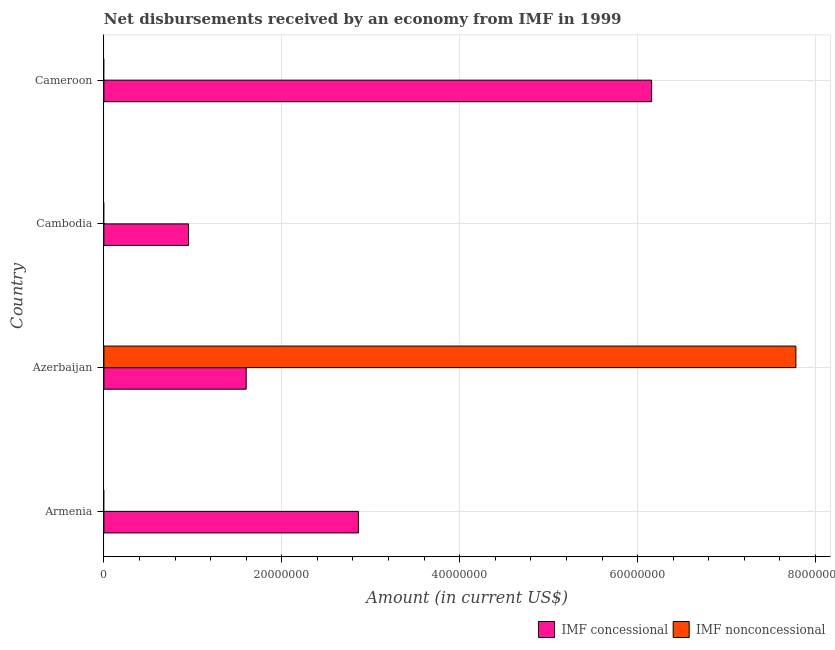Are the number of bars on each tick of the Y-axis equal?
Your answer should be very brief. No. How many bars are there on the 2nd tick from the top?
Give a very brief answer. 1. How many bars are there on the 3rd tick from the bottom?
Keep it short and to the point. 1. What is the label of the 3rd group of bars from the top?
Give a very brief answer. Azerbaijan. In how many cases, is the number of bars for a given country not equal to the number of legend labels?
Provide a succinct answer. 3. What is the net concessional disbursements from imf in Cambodia?
Provide a short and direct response. 9.51e+06. Across all countries, what is the maximum net non concessional disbursements from imf?
Your response must be concise. 7.78e+07. Across all countries, what is the minimum net concessional disbursements from imf?
Keep it short and to the point. 9.51e+06. In which country was the net non concessional disbursements from imf maximum?
Your response must be concise. Azerbaijan. What is the total net concessional disbursements from imf in the graph?
Make the answer very short. 1.16e+08. What is the difference between the net concessional disbursements from imf in Cambodia and that in Cameroon?
Your answer should be very brief. -5.21e+07. What is the difference between the net concessional disbursements from imf in Armenia and the net non concessional disbursements from imf in Cambodia?
Your answer should be very brief. 2.86e+07. What is the average net concessional disbursements from imf per country?
Keep it short and to the point. 2.89e+07. What is the difference between the net concessional disbursements from imf and net non concessional disbursements from imf in Azerbaijan?
Make the answer very short. -6.18e+07. What is the ratio of the net concessional disbursements from imf in Azerbaijan to that in Cameroon?
Your answer should be very brief. 0.26. What is the difference between the highest and the second highest net concessional disbursements from imf?
Keep it short and to the point. 3.30e+07. What is the difference between the highest and the lowest net concessional disbursements from imf?
Keep it short and to the point. 5.21e+07. In how many countries, is the net concessional disbursements from imf greater than the average net concessional disbursements from imf taken over all countries?
Your answer should be compact. 1. Is the sum of the net concessional disbursements from imf in Armenia and Cameroon greater than the maximum net non concessional disbursements from imf across all countries?
Give a very brief answer. Yes. How many countries are there in the graph?
Offer a terse response. 4. Are the values on the major ticks of X-axis written in scientific E-notation?
Your answer should be compact. No. Does the graph contain any zero values?
Provide a short and direct response. Yes. Does the graph contain grids?
Provide a succinct answer. Yes. How many legend labels are there?
Offer a very short reply. 2. What is the title of the graph?
Your answer should be very brief. Net disbursements received by an economy from IMF in 1999. What is the Amount (in current US$) in IMF concessional in Armenia?
Give a very brief answer. 2.86e+07. What is the Amount (in current US$) in IMF concessional in Azerbaijan?
Provide a short and direct response. 1.60e+07. What is the Amount (in current US$) of IMF nonconcessional in Azerbaijan?
Provide a succinct answer. 7.78e+07. What is the Amount (in current US$) in IMF concessional in Cambodia?
Your response must be concise. 9.51e+06. What is the Amount (in current US$) of IMF nonconcessional in Cambodia?
Make the answer very short. 0. What is the Amount (in current US$) of IMF concessional in Cameroon?
Provide a succinct answer. 6.16e+07. Across all countries, what is the maximum Amount (in current US$) of IMF concessional?
Your response must be concise. 6.16e+07. Across all countries, what is the maximum Amount (in current US$) in IMF nonconcessional?
Offer a very short reply. 7.78e+07. Across all countries, what is the minimum Amount (in current US$) of IMF concessional?
Provide a short and direct response. 9.51e+06. What is the total Amount (in current US$) in IMF concessional in the graph?
Your answer should be very brief. 1.16e+08. What is the total Amount (in current US$) in IMF nonconcessional in the graph?
Make the answer very short. 7.78e+07. What is the difference between the Amount (in current US$) of IMF concessional in Armenia and that in Azerbaijan?
Provide a succinct answer. 1.26e+07. What is the difference between the Amount (in current US$) of IMF concessional in Armenia and that in Cambodia?
Your answer should be compact. 1.91e+07. What is the difference between the Amount (in current US$) of IMF concessional in Armenia and that in Cameroon?
Keep it short and to the point. -3.30e+07. What is the difference between the Amount (in current US$) of IMF concessional in Azerbaijan and that in Cambodia?
Your response must be concise. 6.48e+06. What is the difference between the Amount (in current US$) in IMF concessional in Azerbaijan and that in Cameroon?
Keep it short and to the point. -4.56e+07. What is the difference between the Amount (in current US$) in IMF concessional in Cambodia and that in Cameroon?
Provide a succinct answer. -5.21e+07. What is the difference between the Amount (in current US$) of IMF concessional in Armenia and the Amount (in current US$) of IMF nonconcessional in Azerbaijan?
Ensure brevity in your answer.  -4.92e+07. What is the average Amount (in current US$) of IMF concessional per country?
Keep it short and to the point. 2.89e+07. What is the average Amount (in current US$) of IMF nonconcessional per country?
Your answer should be very brief. 1.94e+07. What is the difference between the Amount (in current US$) in IMF concessional and Amount (in current US$) in IMF nonconcessional in Azerbaijan?
Ensure brevity in your answer.  -6.18e+07. What is the ratio of the Amount (in current US$) in IMF concessional in Armenia to that in Azerbaijan?
Offer a very short reply. 1.79. What is the ratio of the Amount (in current US$) in IMF concessional in Armenia to that in Cambodia?
Offer a terse response. 3.01. What is the ratio of the Amount (in current US$) in IMF concessional in Armenia to that in Cameroon?
Give a very brief answer. 0.46. What is the ratio of the Amount (in current US$) of IMF concessional in Azerbaijan to that in Cambodia?
Give a very brief answer. 1.68. What is the ratio of the Amount (in current US$) of IMF concessional in Azerbaijan to that in Cameroon?
Your answer should be very brief. 0.26. What is the ratio of the Amount (in current US$) in IMF concessional in Cambodia to that in Cameroon?
Keep it short and to the point. 0.15. What is the difference between the highest and the second highest Amount (in current US$) of IMF concessional?
Give a very brief answer. 3.30e+07. What is the difference between the highest and the lowest Amount (in current US$) of IMF concessional?
Your response must be concise. 5.21e+07. What is the difference between the highest and the lowest Amount (in current US$) of IMF nonconcessional?
Your answer should be very brief. 7.78e+07. 